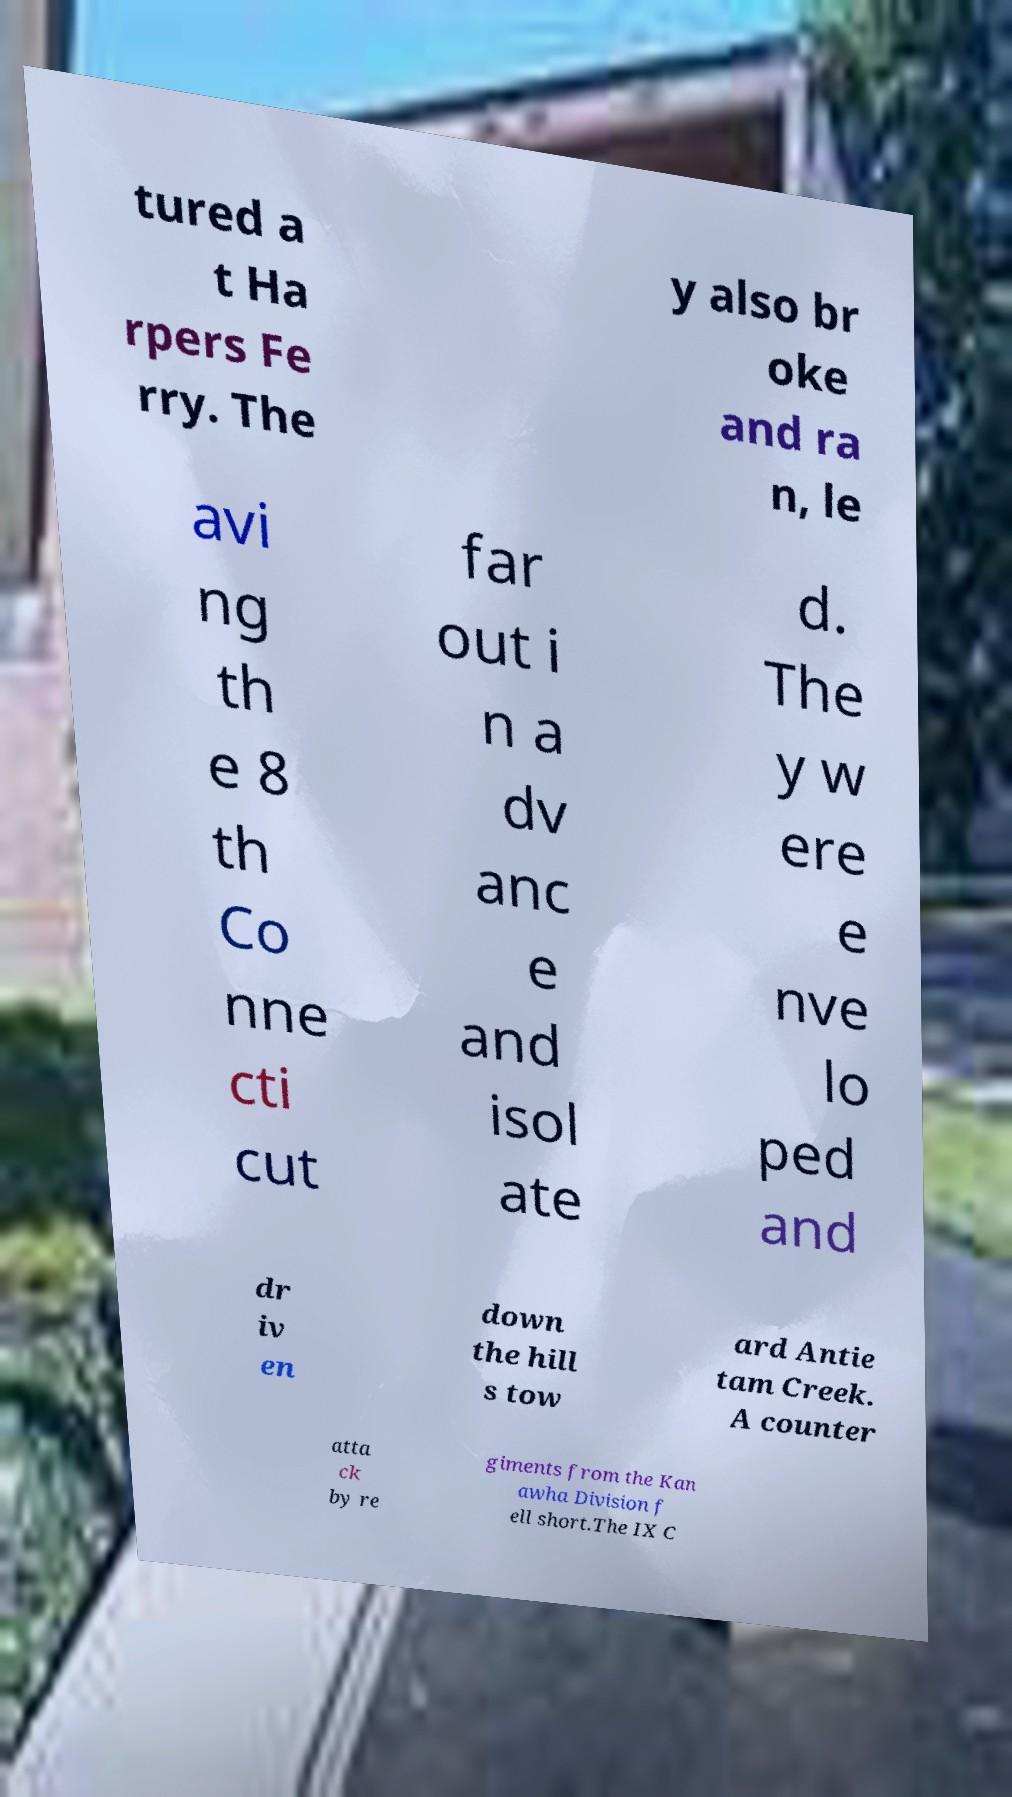There's text embedded in this image that I need extracted. Can you transcribe it verbatim? tured a t Ha rpers Fe rry. The y also br oke and ra n, le avi ng th e 8 th Co nne cti cut far out i n a dv anc e and isol ate d. The y w ere e nve lo ped and dr iv en down the hill s tow ard Antie tam Creek. A counter atta ck by re giments from the Kan awha Division f ell short.The IX C 